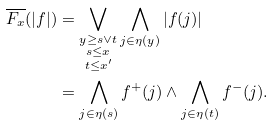<formula> <loc_0><loc_0><loc_500><loc_500>\overline { F _ { x } } ( | f | ) & = \bigvee _ { \substack { y \geq s \vee t \\ s \leq x \\ t \leq x ^ { \prime } } } \bigwedge _ { j \in \eta ( y ) } | f ( j ) | \\ & = \bigwedge _ { j \in \eta ( s ) } f ^ { + } ( j ) \wedge \bigwedge _ { j \in \eta ( t ) } f ^ { - } ( j ) .</formula> 